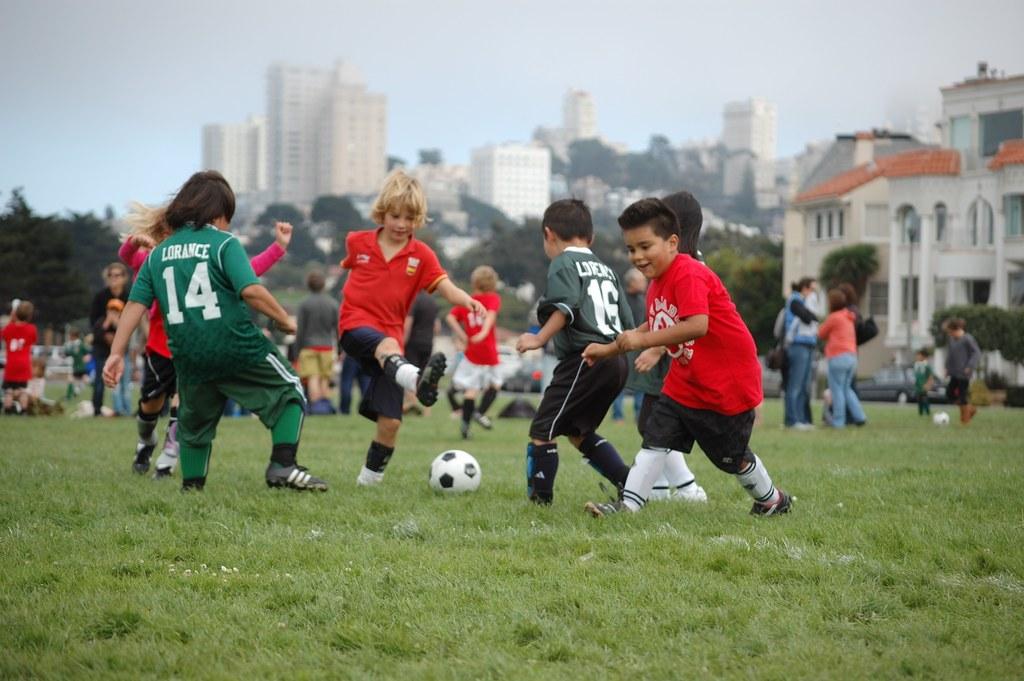Who plays number 14?
Your answer should be compact. Lorance. 